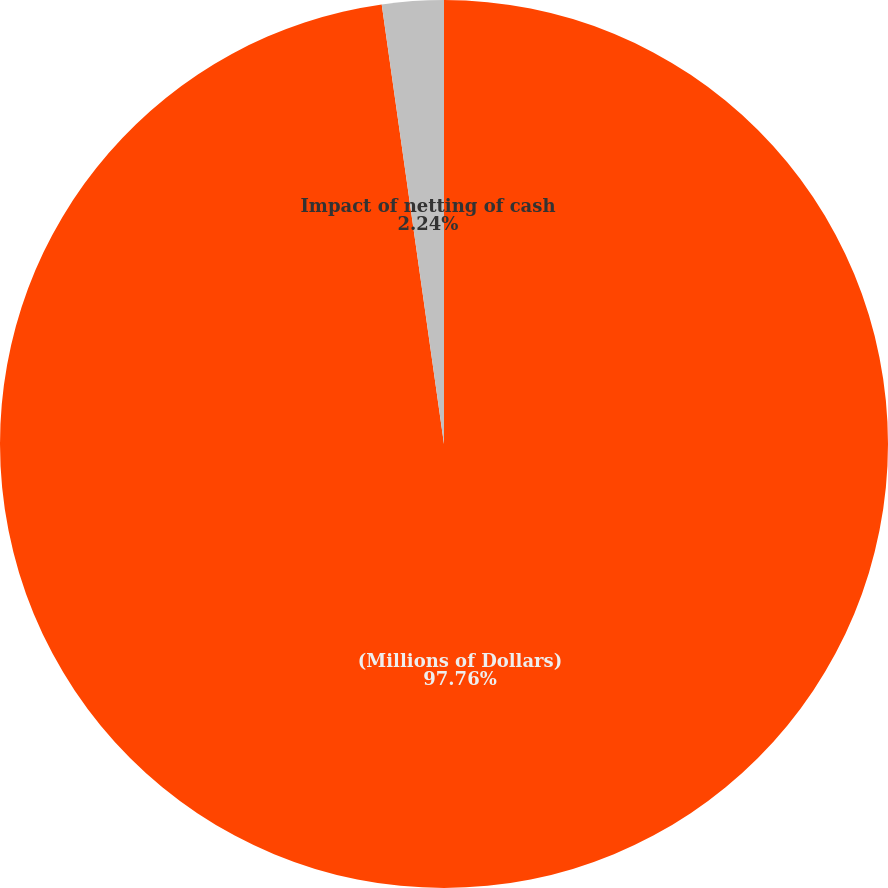Convert chart to OTSL. <chart><loc_0><loc_0><loc_500><loc_500><pie_chart><fcel>(Millions of Dollars)<fcel>Impact of netting of cash<nl><fcel>97.76%<fcel>2.24%<nl></chart> 